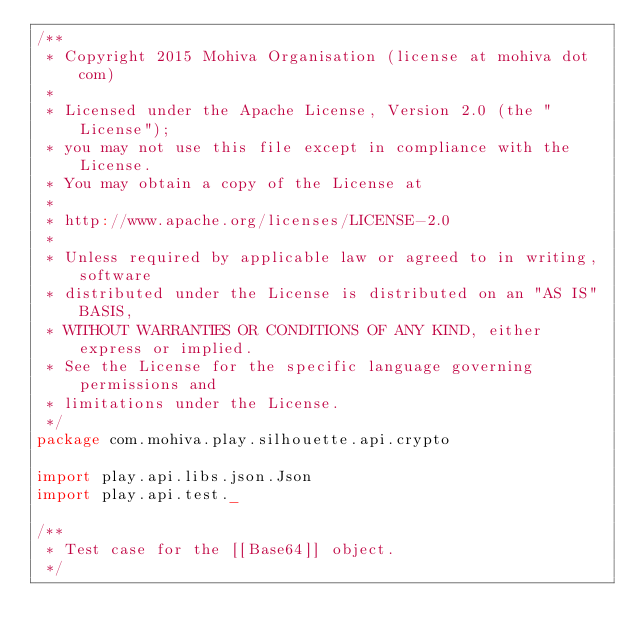Convert code to text. <code><loc_0><loc_0><loc_500><loc_500><_Scala_>/**
 * Copyright 2015 Mohiva Organisation (license at mohiva dot com)
 *
 * Licensed under the Apache License, Version 2.0 (the "License");
 * you may not use this file except in compliance with the License.
 * You may obtain a copy of the License at
 *
 * http://www.apache.org/licenses/LICENSE-2.0
 *
 * Unless required by applicable law or agreed to in writing, software
 * distributed under the License is distributed on an "AS IS" BASIS,
 * WITHOUT WARRANTIES OR CONDITIONS OF ANY KIND, either express or implied.
 * See the License for the specific language governing permissions and
 * limitations under the License.
 */
package com.mohiva.play.silhouette.api.crypto

import play.api.libs.json.Json
import play.api.test._

/**
 * Test case for the [[Base64]] object.
 */</code> 